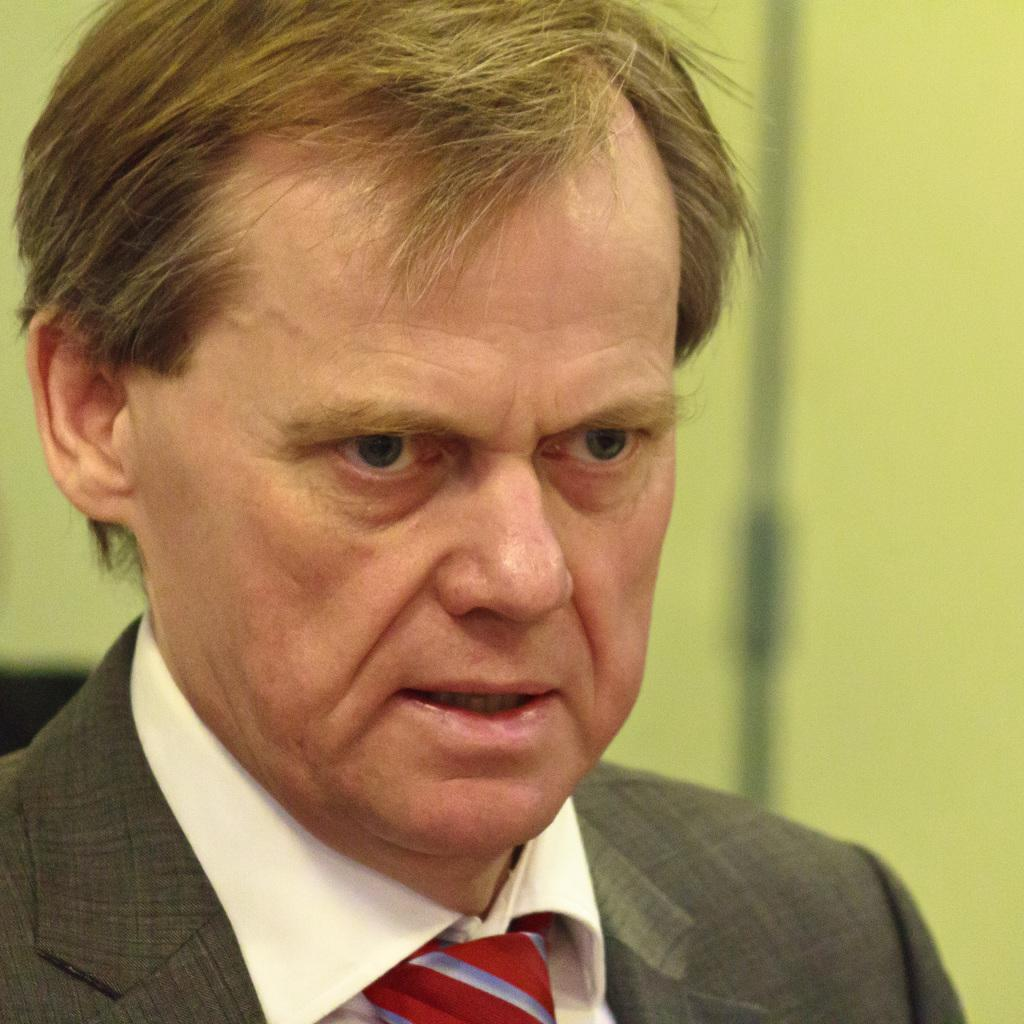Who or what is the main subject in the image? There is a person in the image. What is the person wearing on their upper body? The person is wearing a grey blazer, a white shirt, and a red tie. What color is the background of the image? The background of the image is green. What type of twig can be seen in the person's hand in the image? There is no twig present in the person's hand or in the image. What color are the crayons that the children are using in the image? There are no children or crayons present in the image. 